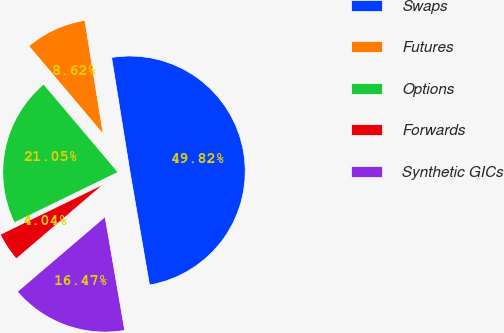Convert chart. <chart><loc_0><loc_0><loc_500><loc_500><pie_chart><fcel>Swaps<fcel>Futures<fcel>Options<fcel>Forwards<fcel>Synthetic GICs<nl><fcel>49.82%<fcel>8.62%<fcel>21.05%<fcel>4.04%<fcel>16.47%<nl></chart> 